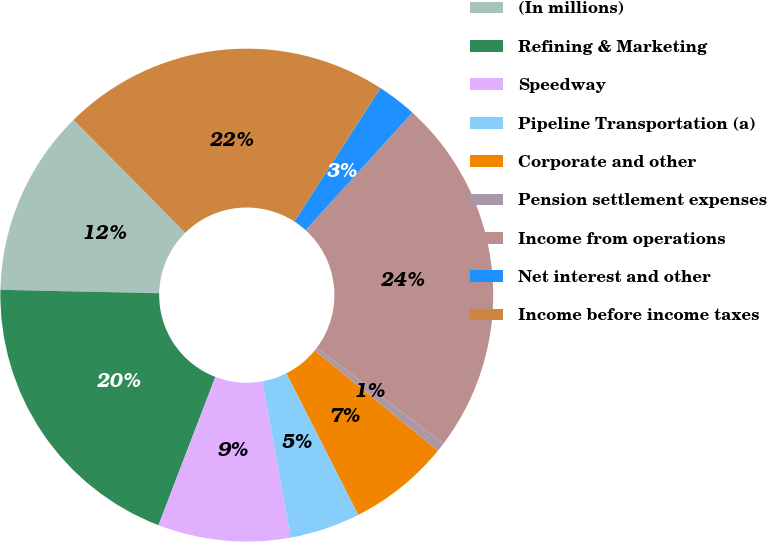<chart> <loc_0><loc_0><loc_500><loc_500><pie_chart><fcel>(In millions)<fcel>Refining & Marketing<fcel>Speedway<fcel>Pipeline Transportation (a)<fcel>Corporate and other<fcel>Pension settlement expenses<fcel>Income from operations<fcel>Net interest and other<fcel>Income before income taxes<nl><fcel>12.25%<fcel>19.51%<fcel>8.68%<fcel>4.63%<fcel>6.66%<fcel>0.58%<fcel>23.56%<fcel>2.6%<fcel>21.53%<nl></chart> 